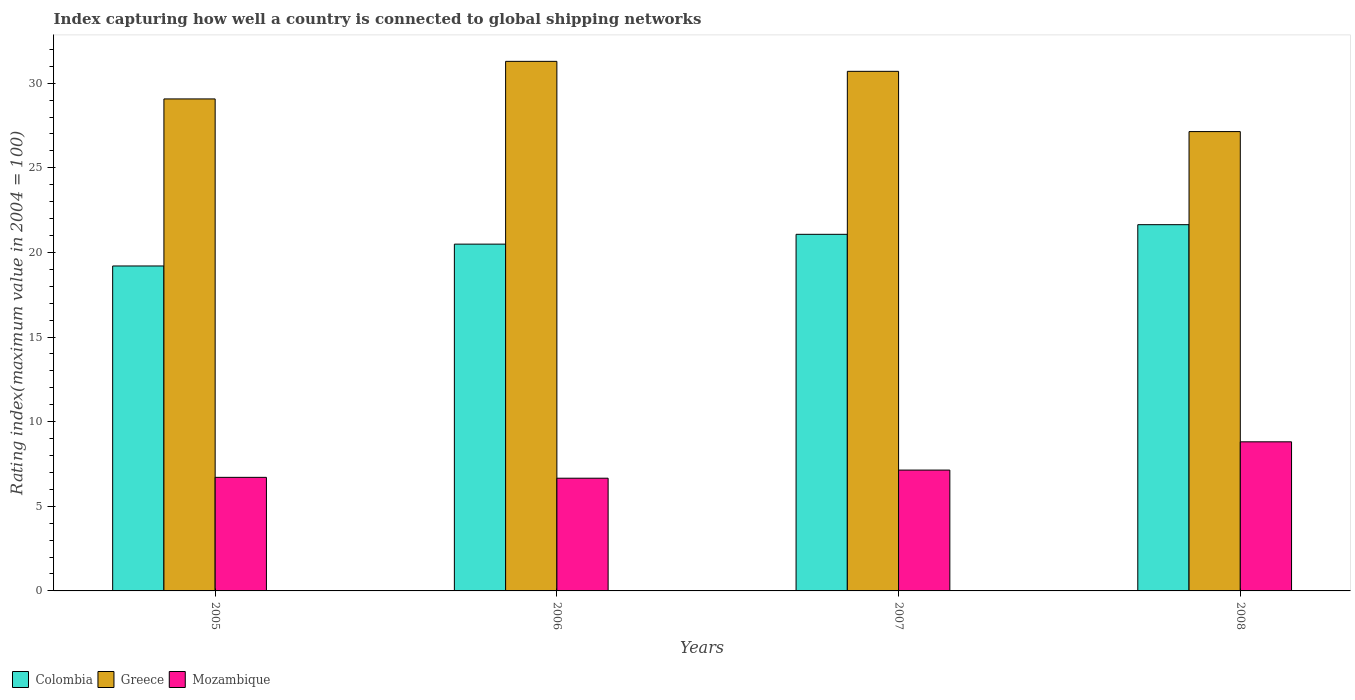Are the number of bars per tick equal to the number of legend labels?
Keep it short and to the point. Yes. Are the number of bars on each tick of the X-axis equal?
Your answer should be compact. Yes. How many bars are there on the 1st tick from the right?
Your answer should be very brief. 3. In how many cases, is the number of bars for a given year not equal to the number of legend labels?
Your answer should be compact. 0. Across all years, what is the maximum rating index in Greece?
Provide a succinct answer. 31.29. Across all years, what is the minimum rating index in Greece?
Keep it short and to the point. 27.14. What is the total rating index in Greece in the graph?
Keep it short and to the point. 118.2. What is the difference between the rating index in Greece in 2005 and that in 2007?
Your answer should be very brief. -1.63. What is the difference between the rating index in Greece in 2008 and the rating index in Mozambique in 2005?
Your answer should be very brief. 20.43. What is the average rating index in Colombia per year?
Give a very brief answer. 20.6. In the year 2008, what is the difference between the rating index in Mozambique and rating index in Colombia?
Keep it short and to the point. -12.83. In how many years, is the rating index in Greece greater than 28?
Your response must be concise. 3. What is the ratio of the rating index in Mozambique in 2005 to that in 2007?
Your answer should be very brief. 0.94. Is the rating index in Colombia in 2007 less than that in 2008?
Provide a succinct answer. Yes. What is the difference between the highest and the second highest rating index in Greece?
Provide a short and direct response. 0.59. What is the difference between the highest and the lowest rating index in Greece?
Your answer should be very brief. 4.15. In how many years, is the rating index in Mozambique greater than the average rating index in Mozambique taken over all years?
Offer a very short reply. 1. What does the 3rd bar from the left in 2007 represents?
Offer a terse response. Mozambique. What does the 1st bar from the right in 2008 represents?
Your answer should be very brief. Mozambique. How many bars are there?
Your answer should be very brief. 12. How many years are there in the graph?
Your answer should be very brief. 4. What is the difference between two consecutive major ticks on the Y-axis?
Give a very brief answer. 5. Are the values on the major ticks of Y-axis written in scientific E-notation?
Give a very brief answer. No. Does the graph contain any zero values?
Keep it short and to the point. No. Does the graph contain grids?
Offer a terse response. No. Where does the legend appear in the graph?
Your response must be concise. Bottom left. How many legend labels are there?
Offer a very short reply. 3. What is the title of the graph?
Provide a succinct answer. Index capturing how well a country is connected to global shipping networks. Does "Antigua and Barbuda" appear as one of the legend labels in the graph?
Your response must be concise. No. What is the label or title of the X-axis?
Keep it short and to the point. Years. What is the label or title of the Y-axis?
Offer a terse response. Rating index(maximum value in 2004 = 100). What is the Rating index(maximum value in 2004 = 100) in Greece in 2005?
Provide a short and direct response. 29.07. What is the Rating index(maximum value in 2004 = 100) in Mozambique in 2005?
Provide a succinct answer. 6.71. What is the Rating index(maximum value in 2004 = 100) of Colombia in 2006?
Your answer should be compact. 20.49. What is the Rating index(maximum value in 2004 = 100) in Greece in 2006?
Your response must be concise. 31.29. What is the Rating index(maximum value in 2004 = 100) of Mozambique in 2006?
Your answer should be very brief. 6.66. What is the Rating index(maximum value in 2004 = 100) in Colombia in 2007?
Your answer should be compact. 21.07. What is the Rating index(maximum value in 2004 = 100) in Greece in 2007?
Offer a terse response. 30.7. What is the Rating index(maximum value in 2004 = 100) in Mozambique in 2007?
Give a very brief answer. 7.14. What is the Rating index(maximum value in 2004 = 100) of Colombia in 2008?
Ensure brevity in your answer.  21.64. What is the Rating index(maximum value in 2004 = 100) of Greece in 2008?
Ensure brevity in your answer.  27.14. What is the Rating index(maximum value in 2004 = 100) in Mozambique in 2008?
Make the answer very short. 8.81. Across all years, what is the maximum Rating index(maximum value in 2004 = 100) of Colombia?
Keep it short and to the point. 21.64. Across all years, what is the maximum Rating index(maximum value in 2004 = 100) of Greece?
Offer a very short reply. 31.29. Across all years, what is the maximum Rating index(maximum value in 2004 = 100) in Mozambique?
Make the answer very short. 8.81. Across all years, what is the minimum Rating index(maximum value in 2004 = 100) of Colombia?
Make the answer very short. 19.2. Across all years, what is the minimum Rating index(maximum value in 2004 = 100) in Greece?
Provide a short and direct response. 27.14. Across all years, what is the minimum Rating index(maximum value in 2004 = 100) of Mozambique?
Your answer should be compact. 6.66. What is the total Rating index(maximum value in 2004 = 100) in Colombia in the graph?
Ensure brevity in your answer.  82.4. What is the total Rating index(maximum value in 2004 = 100) of Greece in the graph?
Make the answer very short. 118.2. What is the total Rating index(maximum value in 2004 = 100) in Mozambique in the graph?
Give a very brief answer. 29.32. What is the difference between the Rating index(maximum value in 2004 = 100) of Colombia in 2005 and that in 2006?
Keep it short and to the point. -1.29. What is the difference between the Rating index(maximum value in 2004 = 100) of Greece in 2005 and that in 2006?
Offer a very short reply. -2.22. What is the difference between the Rating index(maximum value in 2004 = 100) of Colombia in 2005 and that in 2007?
Provide a short and direct response. -1.87. What is the difference between the Rating index(maximum value in 2004 = 100) of Greece in 2005 and that in 2007?
Your answer should be very brief. -1.63. What is the difference between the Rating index(maximum value in 2004 = 100) in Mozambique in 2005 and that in 2007?
Provide a succinct answer. -0.43. What is the difference between the Rating index(maximum value in 2004 = 100) of Colombia in 2005 and that in 2008?
Provide a succinct answer. -2.44. What is the difference between the Rating index(maximum value in 2004 = 100) in Greece in 2005 and that in 2008?
Your response must be concise. 1.93. What is the difference between the Rating index(maximum value in 2004 = 100) of Mozambique in 2005 and that in 2008?
Make the answer very short. -2.1. What is the difference between the Rating index(maximum value in 2004 = 100) of Colombia in 2006 and that in 2007?
Your answer should be compact. -0.58. What is the difference between the Rating index(maximum value in 2004 = 100) of Greece in 2006 and that in 2007?
Offer a terse response. 0.59. What is the difference between the Rating index(maximum value in 2004 = 100) of Mozambique in 2006 and that in 2007?
Provide a short and direct response. -0.48. What is the difference between the Rating index(maximum value in 2004 = 100) in Colombia in 2006 and that in 2008?
Provide a short and direct response. -1.15. What is the difference between the Rating index(maximum value in 2004 = 100) of Greece in 2006 and that in 2008?
Provide a succinct answer. 4.15. What is the difference between the Rating index(maximum value in 2004 = 100) in Mozambique in 2006 and that in 2008?
Provide a short and direct response. -2.15. What is the difference between the Rating index(maximum value in 2004 = 100) of Colombia in 2007 and that in 2008?
Your answer should be very brief. -0.57. What is the difference between the Rating index(maximum value in 2004 = 100) of Greece in 2007 and that in 2008?
Your response must be concise. 3.56. What is the difference between the Rating index(maximum value in 2004 = 100) in Mozambique in 2007 and that in 2008?
Offer a terse response. -1.67. What is the difference between the Rating index(maximum value in 2004 = 100) of Colombia in 2005 and the Rating index(maximum value in 2004 = 100) of Greece in 2006?
Provide a short and direct response. -12.09. What is the difference between the Rating index(maximum value in 2004 = 100) in Colombia in 2005 and the Rating index(maximum value in 2004 = 100) in Mozambique in 2006?
Offer a very short reply. 12.54. What is the difference between the Rating index(maximum value in 2004 = 100) in Greece in 2005 and the Rating index(maximum value in 2004 = 100) in Mozambique in 2006?
Your response must be concise. 22.41. What is the difference between the Rating index(maximum value in 2004 = 100) of Colombia in 2005 and the Rating index(maximum value in 2004 = 100) of Greece in 2007?
Provide a short and direct response. -11.5. What is the difference between the Rating index(maximum value in 2004 = 100) of Colombia in 2005 and the Rating index(maximum value in 2004 = 100) of Mozambique in 2007?
Provide a short and direct response. 12.06. What is the difference between the Rating index(maximum value in 2004 = 100) of Greece in 2005 and the Rating index(maximum value in 2004 = 100) of Mozambique in 2007?
Your answer should be very brief. 21.93. What is the difference between the Rating index(maximum value in 2004 = 100) of Colombia in 2005 and the Rating index(maximum value in 2004 = 100) of Greece in 2008?
Offer a very short reply. -7.94. What is the difference between the Rating index(maximum value in 2004 = 100) in Colombia in 2005 and the Rating index(maximum value in 2004 = 100) in Mozambique in 2008?
Offer a very short reply. 10.39. What is the difference between the Rating index(maximum value in 2004 = 100) in Greece in 2005 and the Rating index(maximum value in 2004 = 100) in Mozambique in 2008?
Offer a terse response. 20.26. What is the difference between the Rating index(maximum value in 2004 = 100) of Colombia in 2006 and the Rating index(maximum value in 2004 = 100) of Greece in 2007?
Offer a terse response. -10.21. What is the difference between the Rating index(maximum value in 2004 = 100) in Colombia in 2006 and the Rating index(maximum value in 2004 = 100) in Mozambique in 2007?
Make the answer very short. 13.35. What is the difference between the Rating index(maximum value in 2004 = 100) of Greece in 2006 and the Rating index(maximum value in 2004 = 100) of Mozambique in 2007?
Your answer should be compact. 24.15. What is the difference between the Rating index(maximum value in 2004 = 100) in Colombia in 2006 and the Rating index(maximum value in 2004 = 100) in Greece in 2008?
Your response must be concise. -6.65. What is the difference between the Rating index(maximum value in 2004 = 100) in Colombia in 2006 and the Rating index(maximum value in 2004 = 100) in Mozambique in 2008?
Your response must be concise. 11.68. What is the difference between the Rating index(maximum value in 2004 = 100) of Greece in 2006 and the Rating index(maximum value in 2004 = 100) of Mozambique in 2008?
Ensure brevity in your answer.  22.48. What is the difference between the Rating index(maximum value in 2004 = 100) of Colombia in 2007 and the Rating index(maximum value in 2004 = 100) of Greece in 2008?
Your answer should be very brief. -6.07. What is the difference between the Rating index(maximum value in 2004 = 100) in Colombia in 2007 and the Rating index(maximum value in 2004 = 100) in Mozambique in 2008?
Make the answer very short. 12.26. What is the difference between the Rating index(maximum value in 2004 = 100) of Greece in 2007 and the Rating index(maximum value in 2004 = 100) of Mozambique in 2008?
Your answer should be very brief. 21.89. What is the average Rating index(maximum value in 2004 = 100) in Colombia per year?
Make the answer very short. 20.6. What is the average Rating index(maximum value in 2004 = 100) of Greece per year?
Make the answer very short. 29.55. What is the average Rating index(maximum value in 2004 = 100) of Mozambique per year?
Offer a terse response. 7.33. In the year 2005, what is the difference between the Rating index(maximum value in 2004 = 100) in Colombia and Rating index(maximum value in 2004 = 100) in Greece?
Provide a short and direct response. -9.87. In the year 2005, what is the difference between the Rating index(maximum value in 2004 = 100) in Colombia and Rating index(maximum value in 2004 = 100) in Mozambique?
Provide a succinct answer. 12.49. In the year 2005, what is the difference between the Rating index(maximum value in 2004 = 100) in Greece and Rating index(maximum value in 2004 = 100) in Mozambique?
Ensure brevity in your answer.  22.36. In the year 2006, what is the difference between the Rating index(maximum value in 2004 = 100) of Colombia and Rating index(maximum value in 2004 = 100) of Mozambique?
Your answer should be compact. 13.83. In the year 2006, what is the difference between the Rating index(maximum value in 2004 = 100) in Greece and Rating index(maximum value in 2004 = 100) in Mozambique?
Your answer should be compact. 24.63. In the year 2007, what is the difference between the Rating index(maximum value in 2004 = 100) of Colombia and Rating index(maximum value in 2004 = 100) of Greece?
Keep it short and to the point. -9.63. In the year 2007, what is the difference between the Rating index(maximum value in 2004 = 100) in Colombia and Rating index(maximum value in 2004 = 100) in Mozambique?
Ensure brevity in your answer.  13.93. In the year 2007, what is the difference between the Rating index(maximum value in 2004 = 100) of Greece and Rating index(maximum value in 2004 = 100) of Mozambique?
Keep it short and to the point. 23.56. In the year 2008, what is the difference between the Rating index(maximum value in 2004 = 100) in Colombia and Rating index(maximum value in 2004 = 100) in Greece?
Your answer should be very brief. -5.5. In the year 2008, what is the difference between the Rating index(maximum value in 2004 = 100) of Colombia and Rating index(maximum value in 2004 = 100) of Mozambique?
Keep it short and to the point. 12.83. In the year 2008, what is the difference between the Rating index(maximum value in 2004 = 100) in Greece and Rating index(maximum value in 2004 = 100) in Mozambique?
Provide a short and direct response. 18.33. What is the ratio of the Rating index(maximum value in 2004 = 100) of Colombia in 2005 to that in 2006?
Make the answer very short. 0.94. What is the ratio of the Rating index(maximum value in 2004 = 100) of Greece in 2005 to that in 2006?
Give a very brief answer. 0.93. What is the ratio of the Rating index(maximum value in 2004 = 100) in Mozambique in 2005 to that in 2006?
Your response must be concise. 1.01. What is the ratio of the Rating index(maximum value in 2004 = 100) in Colombia in 2005 to that in 2007?
Keep it short and to the point. 0.91. What is the ratio of the Rating index(maximum value in 2004 = 100) in Greece in 2005 to that in 2007?
Your answer should be very brief. 0.95. What is the ratio of the Rating index(maximum value in 2004 = 100) in Mozambique in 2005 to that in 2007?
Your response must be concise. 0.94. What is the ratio of the Rating index(maximum value in 2004 = 100) of Colombia in 2005 to that in 2008?
Offer a very short reply. 0.89. What is the ratio of the Rating index(maximum value in 2004 = 100) in Greece in 2005 to that in 2008?
Provide a succinct answer. 1.07. What is the ratio of the Rating index(maximum value in 2004 = 100) of Mozambique in 2005 to that in 2008?
Make the answer very short. 0.76. What is the ratio of the Rating index(maximum value in 2004 = 100) in Colombia in 2006 to that in 2007?
Give a very brief answer. 0.97. What is the ratio of the Rating index(maximum value in 2004 = 100) in Greece in 2006 to that in 2007?
Your answer should be very brief. 1.02. What is the ratio of the Rating index(maximum value in 2004 = 100) in Mozambique in 2006 to that in 2007?
Make the answer very short. 0.93. What is the ratio of the Rating index(maximum value in 2004 = 100) in Colombia in 2006 to that in 2008?
Your answer should be compact. 0.95. What is the ratio of the Rating index(maximum value in 2004 = 100) in Greece in 2006 to that in 2008?
Offer a terse response. 1.15. What is the ratio of the Rating index(maximum value in 2004 = 100) of Mozambique in 2006 to that in 2008?
Offer a terse response. 0.76. What is the ratio of the Rating index(maximum value in 2004 = 100) of Colombia in 2007 to that in 2008?
Make the answer very short. 0.97. What is the ratio of the Rating index(maximum value in 2004 = 100) in Greece in 2007 to that in 2008?
Provide a succinct answer. 1.13. What is the ratio of the Rating index(maximum value in 2004 = 100) in Mozambique in 2007 to that in 2008?
Your response must be concise. 0.81. What is the difference between the highest and the second highest Rating index(maximum value in 2004 = 100) of Colombia?
Your answer should be very brief. 0.57. What is the difference between the highest and the second highest Rating index(maximum value in 2004 = 100) of Greece?
Provide a short and direct response. 0.59. What is the difference between the highest and the second highest Rating index(maximum value in 2004 = 100) in Mozambique?
Your response must be concise. 1.67. What is the difference between the highest and the lowest Rating index(maximum value in 2004 = 100) in Colombia?
Give a very brief answer. 2.44. What is the difference between the highest and the lowest Rating index(maximum value in 2004 = 100) in Greece?
Make the answer very short. 4.15. What is the difference between the highest and the lowest Rating index(maximum value in 2004 = 100) in Mozambique?
Ensure brevity in your answer.  2.15. 